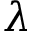Convert formula to latex. <formula><loc_0><loc_0><loc_500><loc_500>\lambda</formula> 